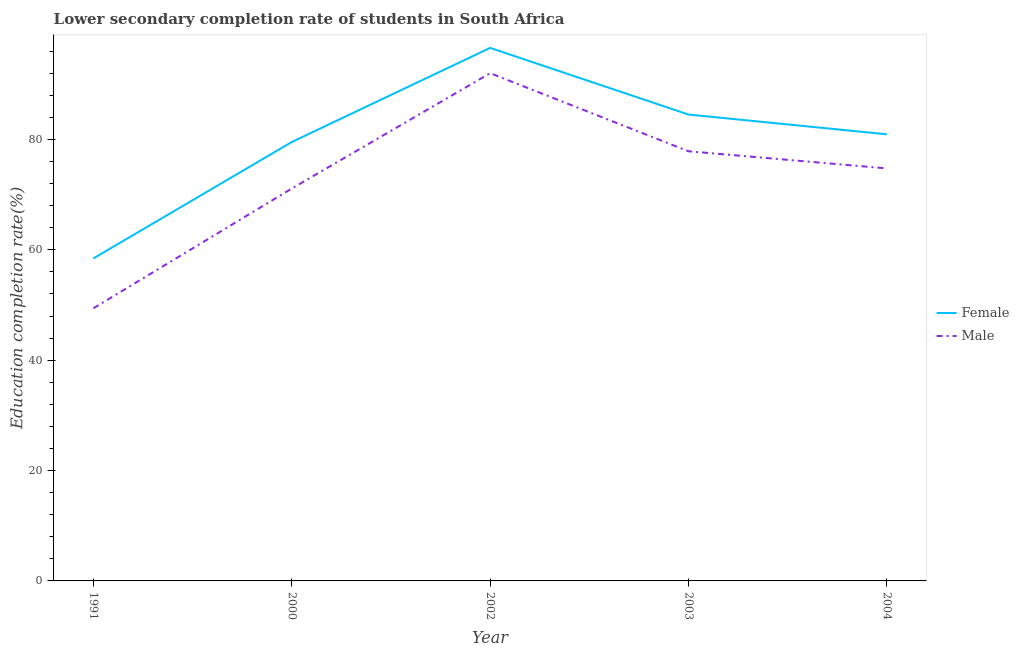How many different coloured lines are there?
Make the answer very short. 2. What is the education completion rate of male students in 1991?
Ensure brevity in your answer.  49.4. Across all years, what is the maximum education completion rate of male students?
Your answer should be compact. 92. Across all years, what is the minimum education completion rate of male students?
Provide a short and direct response. 49.4. In which year was the education completion rate of female students minimum?
Your answer should be compact. 1991. What is the total education completion rate of male students in the graph?
Provide a short and direct response. 365.09. What is the difference between the education completion rate of female students in 1991 and that in 2003?
Offer a very short reply. -26.07. What is the difference between the education completion rate of male students in 1991 and the education completion rate of female students in 2004?
Provide a succinct answer. -31.52. What is the average education completion rate of female students per year?
Your answer should be compact. 79.99. In the year 2004, what is the difference between the education completion rate of female students and education completion rate of male students?
Provide a short and direct response. 6.18. In how many years, is the education completion rate of female students greater than 72 %?
Your response must be concise. 4. What is the ratio of the education completion rate of female students in 2000 to that in 2004?
Offer a very short reply. 0.98. Is the education completion rate of female students in 2002 less than that in 2004?
Your answer should be very brief. No. What is the difference between the highest and the second highest education completion rate of female students?
Offer a terse response. 12.08. What is the difference between the highest and the lowest education completion rate of male students?
Keep it short and to the point. 42.6. Is the sum of the education completion rate of female students in 2003 and 2004 greater than the maximum education completion rate of male students across all years?
Provide a succinct answer. Yes. Does the education completion rate of male students monotonically increase over the years?
Provide a succinct answer. No. Is the education completion rate of male students strictly greater than the education completion rate of female students over the years?
Your response must be concise. No. Is the education completion rate of female students strictly less than the education completion rate of male students over the years?
Your answer should be very brief. No. How many lines are there?
Your answer should be very brief. 2. Are the values on the major ticks of Y-axis written in scientific E-notation?
Give a very brief answer. No. Does the graph contain any zero values?
Your answer should be very brief. No. Does the graph contain grids?
Give a very brief answer. No. How many legend labels are there?
Offer a very short reply. 2. How are the legend labels stacked?
Offer a very short reply. Vertical. What is the title of the graph?
Make the answer very short. Lower secondary completion rate of students in South Africa. Does "Domestic liabilities" appear as one of the legend labels in the graph?
Your answer should be very brief. No. What is the label or title of the Y-axis?
Provide a succinct answer. Education completion rate(%). What is the Education completion rate(%) of Female in 1991?
Provide a short and direct response. 58.43. What is the Education completion rate(%) of Male in 1991?
Provide a succinct answer. 49.4. What is the Education completion rate(%) of Female in 2000?
Provide a succinct answer. 79.52. What is the Education completion rate(%) of Male in 2000?
Your response must be concise. 71.1. What is the Education completion rate(%) in Female in 2002?
Your answer should be compact. 96.58. What is the Education completion rate(%) in Male in 2002?
Provide a succinct answer. 92. What is the Education completion rate(%) of Female in 2003?
Your response must be concise. 84.5. What is the Education completion rate(%) of Male in 2003?
Offer a terse response. 77.85. What is the Education completion rate(%) in Female in 2004?
Offer a very short reply. 80.92. What is the Education completion rate(%) of Male in 2004?
Provide a succinct answer. 74.74. Across all years, what is the maximum Education completion rate(%) of Female?
Offer a terse response. 96.58. Across all years, what is the maximum Education completion rate(%) of Male?
Ensure brevity in your answer.  92. Across all years, what is the minimum Education completion rate(%) in Female?
Your response must be concise. 58.43. Across all years, what is the minimum Education completion rate(%) in Male?
Offer a terse response. 49.4. What is the total Education completion rate(%) in Female in the graph?
Your response must be concise. 399.96. What is the total Education completion rate(%) in Male in the graph?
Offer a very short reply. 365.09. What is the difference between the Education completion rate(%) of Female in 1991 and that in 2000?
Offer a terse response. -21.09. What is the difference between the Education completion rate(%) in Male in 1991 and that in 2000?
Make the answer very short. -21.7. What is the difference between the Education completion rate(%) of Female in 1991 and that in 2002?
Offer a terse response. -38.15. What is the difference between the Education completion rate(%) of Male in 1991 and that in 2002?
Your answer should be compact. -42.6. What is the difference between the Education completion rate(%) in Female in 1991 and that in 2003?
Offer a very short reply. -26.07. What is the difference between the Education completion rate(%) of Male in 1991 and that in 2003?
Your answer should be very brief. -28.45. What is the difference between the Education completion rate(%) in Female in 1991 and that in 2004?
Keep it short and to the point. -22.49. What is the difference between the Education completion rate(%) in Male in 1991 and that in 2004?
Your response must be concise. -25.34. What is the difference between the Education completion rate(%) of Female in 2000 and that in 2002?
Ensure brevity in your answer.  -17.05. What is the difference between the Education completion rate(%) of Male in 2000 and that in 2002?
Provide a short and direct response. -20.9. What is the difference between the Education completion rate(%) in Female in 2000 and that in 2003?
Offer a very short reply. -4.98. What is the difference between the Education completion rate(%) of Male in 2000 and that in 2003?
Keep it short and to the point. -6.75. What is the difference between the Education completion rate(%) in Female in 2000 and that in 2004?
Give a very brief answer. -1.4. What is the difference between the Education completion rate(%) of Male in 2000 and that in 2004?
Your response must be concise. -3.64. What is the difference between the Education completion rate(%) in Female in 2002 and that in 2003?
Your answer should be compact. 12.08. What is the difference between the Education completion rate(%) of Male in 2002 and that in 2003?
Ensure brevity in your answer.  14.15. What is the difference between the Education completion rate(%) in Female in 2002 and that in 2004?
Your answer should be compact. 15.66. What is the difference between the Education completion rate(%) of Male in 2002 and that in 2004?
Ensure brevity in your answer.  17.26. What is the difference between the Education completion rate(%) in Female in 2003 and that in 2004?
Keep it short and to the point. 3.58. What is the difference between the Education completion rate(%) in Male in 2003 and that in 2004?
Offer a terse response. 3.1. What is the difference between the Education completion rate(%) of Female in 1991 and the Education completion rate(%) of Male in 2000?
Your answer should be very brief. -12.67. What is the difference between the Education completion rate(%) of Female in 1991 and the Education completion rate(%) of Male in 2002?
Your answer should be compact. -33.57. What is the difference between the Education completion rate(%) of Female in 1991 and the Education completion rate(%) of Male in 2003?
Your response must be concise. -19.41. What is the difference between the Education completion rate(%) in Female in 1991 and the Education completion rate(%) in Male in 2004?
Provide a succinct answer. -16.31. What is the difference between the Education completion rate(%) of Female in 2000 and the Education completion rate(%) of Male in 2002?
Your answer should be very brief. -12.47. What is the difference between the Education completion rate(%) in Female in 2000 and the Education completion rate(%) in Male in 2003?
Offer a very short reply. 1.68. What is the difference between the Education completion rate(%) of Female in 2000 and the Education completion rate(%) of Male in 2004?
Your response must be concise. 4.78. What is the difference between the Education completion rate(%) of Female in 2002 and the Education completion rate(%) of Male in 2003?
Offer a terse response. 18.73. What is the difference between the Education completion rate(%) of Female in 2002 and the Education completion rate(%) of Male in 2004?
Keep it short and to the point. 21.84. What is the difference between the Education completion rate(%) in Female in 2003 and the Education completion rate(%) in Male in 2004?
Keep it short and to the point. 9.76. What is the average Education completion rate(%) in Female per year?
Provide a succinct answer. 79.99. What is the average Education completion rate(%) in Male per year?
Give a very brief answer. 73.02. In the year 1991, what is the difference between the Education completion rate(%) of Female and Education completion rate(%) of Male?
Provide a short and direct response. 9.03. In the year 2000, what is the difference between the Education completion rate(%) in Female and Education completion rate(%) in Male?
Make the answer very short. 8.42. In the year 2002, what is the difference between the Education completion rate(%) in Female and Education completion rate(%) in Male?
Make the answer very short. 4.58. In the year 2003, what is the difference between the Education completion rate(%) of Female and Education completion rate(%) of Male?
Keep it short and to the point. 6.66. In the year 2004, what is the difference between the Education completion rate(%) of Female and Education completion rate(%) of Male?
Your response must be concise. 6.18. What is the ratio of the Education completion rate(%) in Female in 1991 to that in 2000?
Offer a very short reply. 0.73. What is the ratio of the Education completion rate(%) of Male in 1991 to that in 2000?
Your answer should be compact. 0.69. What is the ratio of the Education completion rate(%) in Female in 1991 to that in 2002?
Provide a short and direct response. 0.6. What is the ratio of the Education completion rate(%) of Male in 1991 to that in 2002?
Provide a succinct answer. 0.54. What is the ratio of the Education completion rate(%) of Female in 1991 to that in 2003?
Provide a succinct answer. 0.69. What is the ratio of the Education completion rate(%) of Male in 1991 to that in 2003?
Provide a short and direct response. 0.63. What is the ratio of the Education completion rate(%) in Female in 1991 to that in 2004?
Your answer should be very brief. 0.72. What is the ratio of the Education completion rate(%) in Male in 1991 to that in 2004?
Your answer should be very brief. 0.66. What is the ratio of the Education completion rate(%) in Female in 2000 to that in 2002?
Your answer should be very brief. 0.82. What is the ratio of the Education completion rate(%) in Male in 2000 to that in 2002?
Your answer should be compact. 0.77. What is the ratio of the Education completion rate(%) of Female in 2000 to that in 2003?
Your answer should be very brief. 0.94. What is the ratio of the Education completion rate(%) in Male in 2000 to that in 2003?
Your answer should be very brief. 0.91. What is the ratio of the Education completion rate(%) of Female in 2000 to that in 2004?
Keep it short and to the point. 0.98. What is the ratio of the Education completion rate(%) in Male in 2000 to that in 2004?
Keep it short and to the point. 0.95. What is the ratio of the Education completion rate(%) of Female in 2002 to that in 2003?
Your answer should be very brief. 1.14. What is the ratio of the Education completion rate(%) of Male in 2002 to that in 2003?
Offer a very short reply. 1.18. What is the ratio of the Education completion rate(%) in Female in 2002 to that in 2004?
Keep it short and to the point. 1.19. What is the ratio of the Education completion rate(%) of Male in 2002 to that in 2004?
Make the answer very short. 1.23. What is the ratio of the Education completion rate(%) of Female in 2003 to that in 2004?
Offer a very short reply. 1.04. What is the ratio of the Education completion rate(%) in Male in 2003 to that in 2004?
Your answer should be very brief. 1.04. What is the difference between the highest and the second highest Education completion rate(%) of Female?
Your response must be concise. 12.08. What is the difference between the highest and the second highest Education completion rate(%) in Male?
Your answer should be very brief. 14.15. What is the difference between the highest and the lowest Education completion rate(%) in Female?
Ensure brevity in your answer.  38.15. What is the difference between the highest and the lowest Education completion rate(%) in Male?
Ensure brevity in your answer.  42.6. 